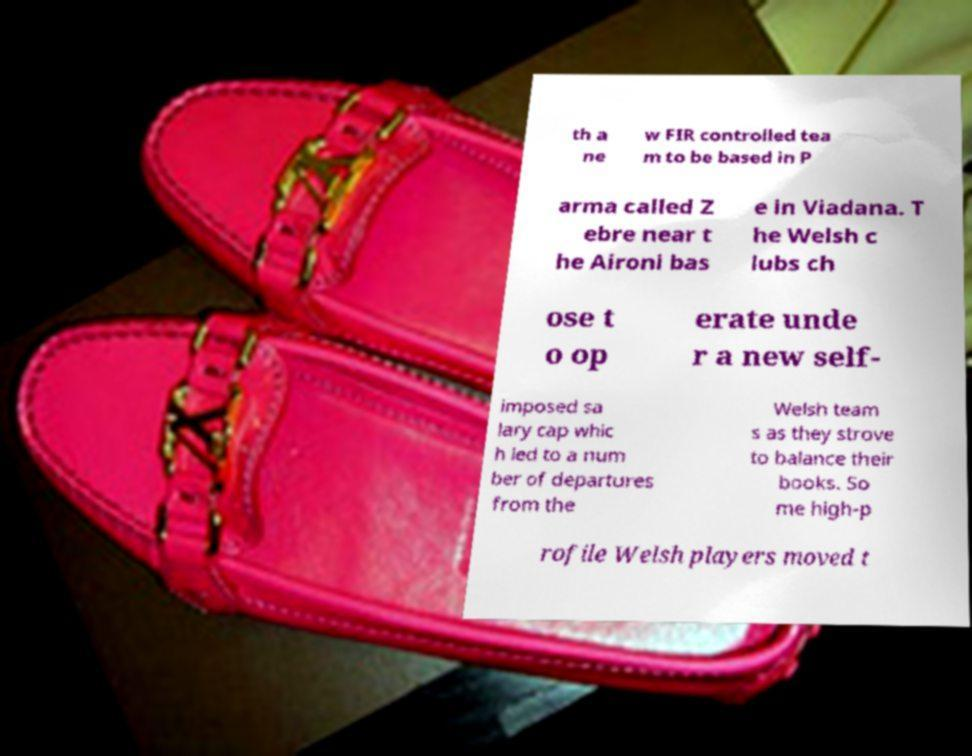There's text embedded in this image that I need extracted. Can you transcribe it verbatim? th a ne w FIR controlled tea m to be based in P arma called Z ebre near t he Aironi bas e in Viadana. T he Welsh c lubs ch ose t o op erate unde r a new self- imposed sa lary cap whic h led to a num ber of departures from the Welsh team s as they strove to balance their books. So me high-p rofile Welsh players moved t 